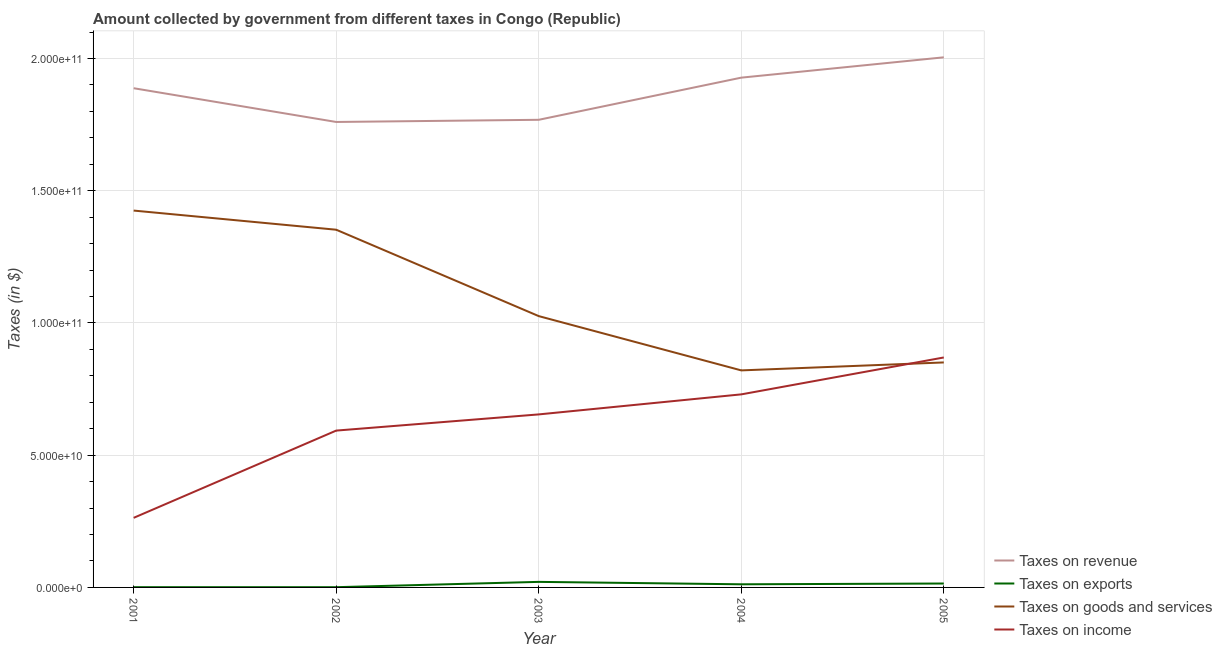How many different coloured lines are there?
Your response must be concise. 4. What is the amount collected as tax on income in 2001?
Your answer should be compact. 2.63e+1. Across all years, what is the maximum amount collected as tax on goods?
Provide a short and direct response. 1.42e+11. Across all years, what is the minimum amount collected as tax on exports?
Ensure brevity in your answer.  9.10e+07. What is the total amount collected as tax on exports in the graph?
Offer a very short reply. 4.95e+09. What is the difference between the amount collected as tax on income in 2001 and that in 2004?
Ensure brevity in your answer.  -4.67e+1. What is the difference between the amount collected as tax on income in 2001 and the amount collected as tax on exports in 2003?
Give a very brief answer. 2.42e+1. What is the average amount collected as tax on goods per year?
Your response must be concise. 1.09e+11. In the year 2001, what is the difference between the amount collected as tax on goods and amount collected as tax on revenue?
Your answer should be very brief. -4.63e+1. In how many years, is the amount collected as tax on revenue greater than 120000000000 $?
Give a very brief answer. 5. What is the ratio of the amount collected as tax on income in 2003 to that in 2005?
Your answer should be very brief. 0.75. Is the amount collected as tax on goods in 2002 less than that in 2003?
Your answer should be compact. No. Is the difference between the amount collected as tax on income in 2002 and 2004 greater than the difference between the amount collected as tax on goods in 2002 and 2004?
Offer a terse response. No. What is the difference between the highest and the second highest amount collected as tax on income?
Provide a short and direct response. 1.40e+1. What is the difference between the highest and the lowest amount collected as tax on income?
Offer a very short reply. 6.06e+1. Is the sum of the amount collected as tax on revenue in 2001 and 2002 greater than the maximum amount collected as tax on goods across all years?
Your answer should be compact. Yes. Is it the case that in every year, the sum of the amount collected as tax on revenue and amount collected as tax on goods is greater than the sum of amount collected as tax on income and amount collected as tax on exports?
Offer a very short reply. Yes. Does the amount collected as tax on exports monotonically increase over the years?
Provide a succinct answer. No. How many years are there in the graph?
Give a very brief answer. 5. What is the difference between two consecutive major ticks on the Y-axis?
Your answer should be compact. 5.00e+1. Does the graph contain grids?
Keep it short and to the point. Yes. Where does the legend appear in the graph?
Give a very brief answer. Bottom right. How many legend labels are there?
Offer a very short reply. 4. How are the legend labels stacked?
Make the answer very short. Vertical. What is the title of the graph?
Ensure brevity in your answer.  Amount collected by government from different taxes in Congo (Republic). Does "Other greenhouse gases" appear as one of the legend labels in the graph?
Give a very brief answer. No. What is the label or title of the Y-axis?
Your answer should be compact. Taxes (in $). What is the Taxes (in $) of Taxes on revenue in 2001?
Your answer should be compact. 1.89e+11. What is the Taxes (in $) in Taxes on exports in 2001?
Provide a short and direct response. 9.72e+07. What is the Taxes (in $) of Taxes on goods and services in 2001?
Your answer should be compact. 1.42e+11. What is the Taxes (in $) in Taxes on income in 2001?
Ensure brevity in your answer.  2.63e+1. What is the Taxes (in $) of Taxes on revenue in 2002?
Provide a short and direct response. 1.76e+11. What is the Taxes (in $) of Taxes on exports in 2002?
Make the answer very short. 9.10e+07. What is the Taxes (in $) of Taxes on goods and services in 2002?
Make the answer very short. 1.35e+11. What is the Taxes (in $) of Taxes on income in 2002?
Ensure brevity in your answer.  5.93e+1. What is the Taxes (in $) in Taxes on revenue in 2003?
Your response must be concise. 1.77e+11. What is the Taxes (in $) in Taxes on exports in 2003?
Provide a short and direct response. 2.10e+09. What is the Taxes (in $) of Taxes on goods and services in 2003?
Offer a terse response. 1.03e+11. What is the Taxes (in $) in Taxes on income in 2003?
Your answer should be very brief. 6.54e+1. What is the Taxes (in $) of Taxes on revenue in 2004?
Keep it short and to the point. 1.93e+11. What is the Taxes (in $) of Taxes on exports in 2004?
Ensure brevity in your answer.  1.18e+09. What is the Taxes (in $) in Taxes on goods and services in 2004?
Ensure brevity in your answer.  8.21e+1. What is the Taxes (in $) in Taxes on income in 2004?
Your answer should be compact. 7.30e+1. What is the Taxes (in $) in Taxes on revenue in 2005?
Ensure brevity in your answer.  2.00e+11. What is the Taxes (in $) in Taxes on exports in 2005?
Your answer should be compact. 1.48e+09. What is the Taxes (in $) of Taxes on goods and services in 2005?
Ensure brevity in your answer.  8.51e+1. What is the Taxes (in $) in Taxes on income in 2005?
Your answer should be very brief. 8.70e+1. Across all years, what is the maximum Taxes (in $) in Taxes on revenue?
Offer a very short reply. 2.00e+11. Across all years, what is the maximum Taxes (in $) in Taxes on exports?
Your response must be concise. 2.10e+09. Across all years, what is the maximum Taxes (in $) of Taxes on goods and services?
Provide a short and direct response. 1.42e+11. Across all years, what is the maximum Taxes (in $) of Taxes on income?
Offer a terse response. 8.70e+1. Across all years, what is the minimum Taxes (in $) in Taxes on revenue?
Your response must be concise. 1.76e+11. Across all years, what is the minimum Taxes (in $) in Taxes on exports?
Provide a short and direct response. 9.10e+07. Across all years, what is the minimum Taxes (in $) of Taxes on goods and services?
Ensure brevity in your answer.  8.21e+1. Across all years, what is the minimum Taxes (in $) in Taxes on income?
Provide a short and direct response. 2.63e+1. What is the total Taxes (in $) of Taxes on revenue in the graph?
Offer a terse response. 9.35e+11. What is the total Taxes (in $) of Taxes on exports in the graph?
Offer a terse response. 4.95e+09. What is the total Taxes (in $) of Taxes on goods and services in the graph?
Keep it short and to the point. 5.47e+11. What is the total Taxes (in $) of Taxes on income in the graph?
Give a very brief answer. 3.11e+11. What is the difference between the Taxes (in $) in Taxes on revenue in 2001 and that in 2002?
Your answer should be compact. 1.28e+1. What is the difference between the Taxes (in $) of Taxes on exports in 2001 and that in 2002?
Your answer should be very brief. 6.21e+06. What is the difference between the Taxes (in $) of Taxes on goods and services in 2001 and that in 2002?
Provide a succinct answer. 7.24e+09. What is the difference between the Taxes (in $) in Taxes on income in 2001 and that in 2002?
Provide a short and direct response. -3.30e+1. What is the difference between the Taxes (in $) in Taxes on revenue in 2001 and that in 2003?
Give a very brief answer. 1.19e+1. What is the difference between the Taxes (in $) in Taxes on exports in 2001 and that in 2003?
Your answer should be compact. -2.00e+09. What is the difference between the Taxes (in $) in Taxes on goods and services in 2001 and that in 2003?
Ensure brevity in your answer.  3.99e+1. What is the difference between the Taxes (in $) of Taxes on income in 2001 and that in 2003?
Give a very brief answer. -3.91e+1. What is the difference between the Taxes (in $) of Taxes on revenue in 2001 and that in 2004?
Give a very brief answer. -4.00e+09. What is the difference between the Taxes (in $) in Taxes on exports in 2001 and that in 2004?
Make the answer very short. -1.09e+09. What is the difference between the Taxes (in $) in Taxes on goods and services in 2001 and that in 2004?
Provide a short and direct response. 6.04e+1. What is the difference between the Taxes (in $) of Taxes on income in 2001 and that in 2004?
Ensure brevity in your answer.  -4.67e+1. What is the difference between the Taxes (in $) in Taxes on revenue in 2001 and that in 2005?
Offer a very short reply. -1.17e+1. What is the difference between the Taxes (in $) of Taxes on exports in 2001 and that in 2005?
Your answer should be very brief. -1.38e+09. What is the difference between the Taxes (in $) in Taxes on goods and services in 2001 and that in 2005?
Your answer should be compact. 5.74e+1. What is the difference between the Taxes (in $) in Taxes on income in 2001 and that in 2005?
Keep it short and to the point. -6.06e+1. What is the difference between the Taxes (in $) of Taxes on revenue in 2002 and that in 2003?
Keep it short and to the point. -8.23e+08. What is the difference between the Taxes (in $) in Taxes on exports in 2002 and that in 2003?
Make the answer very short. -2.01e+09. What is the difference between the Taxes (in $) in Taxes on goods and services in 2002 and that in 2003?
Offer a terse response. 3.27e+1. What is the difference between the Taxes (in $) of Taxes on income in 2002 and that in 2003?
Offer a terse response. -6.12e+09. What is the difference between the Taxes (in $) in Taxes on revenue in 2002 and that in 2004?
Provide a succinct answer. -1.68e+1. What is the difference between the Taxes (in $) of Taxes on exports in 2002 and that in 2004?
Offer a very short reply. -1.09e+09. What is the difference between the Taxes (in $) of Taxes on goods and services in 2002 and that in 2004?
Your answer should be compact. 5.32e+1. What is the difference between the Taxes (in $) of Taxes on income in 2002 and that in 2004?
Give a very brief answer. -1.37e+1. What is the difference between the Taxes (in $) in Taxes on revenue in 2002 and that in 2005?
Keep it short and to the point. -2.44e+1. What is the difference between the Taxes (in $) in Taxes on exports in 2002 and that in 2005?
Give a very brief answer. -1.39e+09. What is the difference between the Taxes (in $) of Taxes on goods and services in 2002 and that in 2005?
Give a very brief answer. 5.02e+1. What is the difference between the Taxes (in $) of Taxes on income in 2002 and that in 2005?
Give a very brief answer. -2.77e+1. What is the difference between the Taxes (in $) in Taxes on revenue in 2003 and that in 2004?
Your answer should be compact. -1.59e+1. What is the difference between the Taxes (in $) in Taxes on exports in 2003 and that in 2004?
Your response must be concise. 9.16e+08. What is the difference between the Taxes (in $) in Taxes on goods and services in 2003 and that in 2004?
Your response must be concise. 2.05e+1. What is the difference between the Taxes (in $) of Taxes on income in 2003 and that in 2004?
Your answer should be compact. -7.58e+09. What is the difference between the Taxes (in $) in Taxes on revenue in 2003 and that in 2005?
Give a very brief answer. -2.36e+1. What is the difference between the Taxes (in $) in Taxes on exports in 2003 and that in 2005?
Your response must be concise. 6.22e+08. What is the difference between the Taxes (in $) in Taxes on goods and services in 2003 and that in 2005?
Your response must be concise. 1.75e+1. What is the difference between the Taxes (in $) in Taxes on income in 2003 and that in 2005?
Provide a short and direct response. -2.15e+1. What is the difference between the Taxes (in $) of Taxes on revenue in 2004 and that in 2005?
Your answer should be compact. -7.69e+09. What is the difference between the Taxes (in $) of Taxes on exports in 2004 and that in 2005?
Keep it short and to the point. -2.94e+08. What is the difference between the Taxes (in $) in Taxes on goods and services in 2004 and that in 2005?
Offer a very short reply. -3.01e+09. What is the difference between the Taxes (in $) of Taxes on income in 2004 and that in 2005?
Provide a succinct answer. -1.40e+1. What is the difference between the Taxes (in $) of Taxes on revenue in 2001 and the Taxes (in $) of Taxes on exports in 2002?
Provide a succinct answer. 1.89e+11. What is the difference between the Taxes (in $) of Taxes on revenue in 2001 and the Taxes (in $) of Taxes on goods and services in 2002?
Offer a terse response. 5.35e+1. What is the difference between the Taxes (in $) of Taxes on revenue in 2001 and the Taxes (in $) of Taxes on income in 2002?
Make the answer very short. 1.29e+11. What is the difference between the Taxes (in $) of Taxes on exports in 2001 and the Taxes (in $) of Taxes on goods and services in 2002?
Provide a succinct answer. -1.35e+11. What is the difference between the Taxes (in $) of Taxes on exports in 2001 and the Taxes (in $) of Taxes on income in 2002?
Provide a short and direct response. -5.92e+1. What is the difference between the Taxes (in $) in Taxes on goods and services in 2001 and the Taxes (in $) in Taxes on income in 2002?
Offer a terse response. 8.32e+1. What is the difference between the Taxes (in $) in Taxes on revenue in 2001 and the Taxes (in $) in Taxes on exports in 2003?
Your response must be concise. 1.87e+11. What is the difference between the Taxes (in $) of Taxes on revenue in 2001 and the Taxes (in $) of Taxes on goods and services in 2003?
Give a very brief answer. 8.62e+1. What is the difference between the Taxes (in $) in Taxes on revenue in 2001 and the Taxes (in $) in Taxes on income in 2003?
Provide a succinct answer. 1.23e+11. What is the difference between the Taxes (in $) of Taxes on exports in 2001 and the Taxes (in $) of Taxes on goods and services in 2003?
Provide a short and direct response. -1.02e+11. What is the difference between the Taxes (in $) in Taxes on exports in 2001 and the Taxes (in $) in Taxes on income in 2003?
Your response must be concise. -6.53e+1. What is the difference between the Taxes (in $) in Taxes on goods and services in 2001 and the Taxes (in $) in Taxes on income in 2003?
Keep it short and to the point. 7.71e+1. What is the difference between the Taxes (in $) of Taxes on revenue in 2001 and the Taxes (in $) of Taxes on exports in 2004?
Keep it short and to the point. 1.88e+11. What is the difference between the Taxes (in $) in Taxes on revenue in 2001 and the Taxes (in $) in Taxes on goods and services in 2004?
Offer a terse response. 1.07e+11. What is the difference between the Taxes (in $) in Taxes on revenue in 2001 and the Taxes (in $) in Taxes on income in 2004?
Keep it short and to the point. 1.16e+11. What is the difference between the Taxes (in $) in Taxes on exports in 2001 and the Taxes (in $) in Taxes on goods and services in 2004?
Keep it short and to the point. -8.20e+1. What is the difference between the Taxes (in $) in Taxes on exports in 2001 and the Taxes (in $) in Taxes on income in 2004?
Ensure brevity in your answer.  -7.29e+1. What is the difference between the Taxes (in $) of Taxes on goods and services in 2001 and the Taxes (in $) of Taxes on income in 2004?
Provide a succinct answer. 6.95e+1. What is the difference between the Taxes (in $) of Taxes on revenue in 2001 and the Taxes (in $) of Taxes on exports in 2005?
Give a very brief answer. 1.87e+11. What is the difference between the Taxes (in $) of Taxes on revenue in 2001 and the Taxes (in $) of Taxes on goods and services in 2005?
Give a very brief answer. 1.04e+11. What is the difference between the Taxes (in $) of Taxes on revenue in 2001 and the Taxes (in $) of Taxes on income in 2005?
Keep it short and to the point. 1.02e+11. What is the difference between the Taxes (in $) of Taxes on exports in 2001 and the Taxes (in $) of Taxes on goods and services in 2005?
Your answer should be compact. -8.50e+1. What is the difference between the Taxes (in $) in Taxes on exports in 2001 and the Taxes (in $) in Taxes on income in 2005?
Your answer should be compact. -8.69e+1. What is the difference between the Taxes (in $) in Taxes on goods and services in 2001 and the Taxes (in $) in Taxes on income in 2005?
Provide a succinct answer. 5.55e+1. What is the difference between the Taxes (in $) of Taxes on revenue in 2002 and the Taxes (in $) of Taxes on exports in 2003?
Make the answer very short. 1.74e+11. What is the difference between the Taxes (in $) in Taxes on revenue in 2002 and the Taxes (in $) in Taxes on goods and services in 2003?
Ensure brevity in your answer.  7.34e+1. What is the difference between the Taxes (in $) of Taxes on revenue in 2002 and the Taxes (in $) of Taxes on income in 2003?
Offer a terse response. 1.11e+11. What is the difference between the Taxes (in $) in Taxes on exports in 2002 and the Taxes (in $) in Taxes on goods and services in 2003?
Your answer should be very brief. -1.03e+11. What is the difference between the Taxes (in $) in Taxes on exports in 2002 and the Taxes (in $) in Taxes on income in 2003?
Give a very brief answer. -6.53e+1. What is the difference between the Taxes (in $) of Taxes on goods and services in 2002 and the Taxes (in $) of Taxes on income in 2003?
Keep it short and to the point. 6.98e+1. What is the difference between the Taxes (in $) in Taxes on revenue in 2002 and the Taxes (in $) in Taxes on exports in 2004?
Offer a terse response. 1.75e+11. What is the difference between the Taxes (in $) in Taxes on revenue in 2002 and the Taxes (in $) in Taxes on goods and services in 2004?
Your answer should be compact. 9.39e+1. What is the difference between the Taxes (in $) of Taxes on revenue in 2002 and the Taxes (in $) of Taxes on income in 2004?
Provide a short and direct response. 1.03e+11. What is the difference between the Taxes (in $) of Taxes on exports in 2002 and the Taxes (in $) of Taxes on goods and services in 2004?
Keep it short and to the point. -8.20e+1. What is the difference between the Taxes (in $) in Taxes on exports in 2002 and the Taxes (in $) in Taxes on income in 2004?
Make the answer very short. -7.29e+1. What is the difference between the Taxes (in $) in Taxes on goods and services in 2002 and the Taxes (in $) in Taxes on income in 2004?
Your response must be concise. 6.23e+1. What is the difference between the Taxes (in $) in Taxes on revenue in 2002 and the Taxes (in $) in Taxes on exports in 2005?
Your answer should be very brief. 1.75e+11. What is the difference between the Taxes (in $) of Taxes on revenue in 2002 and the Taxes (in $) of Taxes on goods and services in 2005?
Your answer should be compact. 9.09e+1. What is the difference between the Taxes (in $) in Taxes on revenue in 2002 and the Taxes (in $) in Taxes on income in 2005?
Give a very brief answer. 8.90e+1. What is the difference between the Taxes (in $) in Taxes on exports in 2002 and the Taxes (in $) in Taxes on goods and services in 2005?
Provide a succinct answer. -8.50e+1. What is the difference between the Taxes (in $) in Taxes on exports in 2002 and the Taxes (in $) in Taxes on income in 2005?
Make the answer very short. -8.69e+1. What is the difference between the Taxes (in $) of Taxes on goods and services in 2002 and the Taxes (in $) of Taxes on income in 2005?
Keep it short and to the point. 4.83e+1. What is the difference between the Taxes (in $) of Taxes on revenue in 2003 and the Taxes (in $) of Taxes on exports in 2004?
Your answer should be compact. 1.76e+11. What is the difference between the Taxes (in $) of Taxes on revenue in 2003 and the Taxes (in $) of Taxes on goods and services in 2004?
Your response must be concise. 9.48e+1. What is the difference between the Taxes (in $) in Taxes on revenue in 2003 and the Taxes (in $) in Taxes on income in 2004?
Offer a very short reply. 1.04e+11. What is the difference between the Taxes (in $) in Taxes on exports in 2003 and the Taxes (in $) in Taxes on goods and services in 2004?
Your answer should be compact. -8.00e+1. What is the difference between the Taxes (in $) of Taxes on exports in 2003 and the Taxes (in $) of Taxes on income in 2004?
Make the answer very short. -7.09e+1. What is the difference between the Taxes (in $) in Taxes on goods and services in 2003 and the Taxes (in $) in Taxes on income in 2004?
Your answer should be compact. 2.96e+1. What is the difference between the Taxes (in $) of Taxes on revenue in 2003 and the Taxes (in $) of Taxes on exports in 2005?
Your answer should be compact. 1.75e+11. What is the difference between the Taxes (in $) in Taxes on revenue in 2003 and the Taxes (in $) in Taxes on goods and services in 2005?
Provide a succinct answer. 9.17e+1. What is the difference between the Taxes (in $) in Taxes on revenue in 2003 and the Taxes (in $) in Taxes on income in 2005?
Provide a succinct answer. 8.99e+1. What is the difference between the Taxes (in $) in Taxes on exports in 2003 and the Taxes (in $) in Taxes on goods and services in 2005?
Keep it short and to the point. -8.30e+1. What is the difference between the Taxes (in $) of Taxes on exports in 2003 and the Taxes (in $) of Taxes on income in 2005?
Your response must be concise. -8.49e+1. What is the difference between the Taxes (in $) of Taxes on goods and services in 2003 and the Taxes (in $) of Taxes on income in 2005?
Provide a succinct answer. 1.56e+1. What is the difference between the Taxes (in $) of Taxes on revenue in 2004 and the Taxes (in $) of Taxes on exports in 2005?
Provide a succinct answer. 1.91e+11. What is the difference between the Taxes (in $) in Taxes on revenue in 2004 and the Taxes (in $) in Taxes on goods and services in 2005?
Your response must be concise. 1.08e+11. What is the difference between the Taxes (in $) in Taxes on revenue in 2004 and the Taxes (in $) in Taxes on income in 2005?
Provide a short and direct response. 1.06e+11. What is the difference between the Taxes (in $) in Taxes on exports in 2004 and the Taxes (in $) in Taxes on goods and services in 2005?
Your answer should be compact. -8.39e+1. What is the difference between the Taxes (in $) of Taxes on exports in 2004 and the Taxes (in $) of Taxes on income in 2005?
Your answer should be very brief. -8.58e+1. What is the difference between the Taxes (in $) of Taxes on goods and services in 2004 and the Taxes (in $) of Taxes on income in 2005?
Keep it short and to the point. -4.89e+09. What is the average Taxes (in $) of Taxes on revenue per year?
Offer a terse response. 1.87e+11. What is the average Taxes (in $) in Taxes on exports per year?
Keep it short and to the point. 9.90e+08. What is the average Taxes (in $) in Taxes on goods and services per year?
Keep it short and to the point. 1.09e+11. What is the average Taxes (in $) of Taxes on income per year?
Offer a terse response. 6.22e+1. In the year 2001, what is the difference between the Taxes (in $) in Taxes on revenue and Taxes (in $) in Taxes on exports?
Make the answer very short. 1.89e+11. In the year 2001, what is the difference between the Taxes (in $) in Taxes on revenue and Taxes (in $) in Taxes on goods and services?
Keep it short and to the point. 4.63e+1. In the year 2001, what is the difference between the Taxes (in $) in Taxes on revenue and Taxes (in $) in Taxes on income?
Give a very brief answer. 1.62e+11. In the year 2001, what is the difference between the Taxes (in $) in Taxes on exports and Taxes (in $) in Taxes on goods and services?
Offer a very short reply. -1.42e+11. In the year 2001, what is the difference between the Taxes (in $) of Taxes on exports and Taxes (in $) of Taxes on income?
Give a very brief answer. -2.62e+1. In the year 2001, what is the difference between the Taxes (in $) of Taxes on goods and services and Taxes (in $) of Taxes on income?
Your response must be concise. 1.16e+11. In the year 2002, what is the difference between the Taxes (in $) of Taxes on revenue and Taxes (in $) of Taxes on exports?
Provide a short and direct response. 1.76e+11. In the year 2002, what is the difference between the Taxes (in $) of Taxes on revenue and Taxes (in $) of Taxes on goods and services?
Your response must be concise. 4.07e+1. In the year 2002, what is the difference between the Taxes (in $) of Taxes on revenue and Taxes (in $) of Taxes on income?
Keep it short and to the point. 1.17e+11. In the year 2002, what is the difference between the Taxes (in $) of Taxes on exports and Taxes (in $) of Taxes on goods and services?
Keep it short and to the point. -1.35e+11. In the year 2002, what is the difference between the Taxes (in $) in Taxes on exports and Taxes (in $) in Taxes on income?
Provide a succinct answer. -5.92e+1. In the year 2002, what is the difference between the Taxes (in $) in Taxes on goods and services and Taxes (in $) in Taxes on income?
Make the answer very short. 7.60e+1. In the year 2003, what is the difference between the Taxes (in $) in Taxes on revenue and Taxes (in $) in Taxes on exports?
Give a very brief answer. 1.75e+11. In the year 2003, what is the difference between the Taxes (in $) of Taxes on revenue and Taxes (in $) of Taxes on goods and services?
Offer a terse response. 7.42e+1. In the year 2003, what is the difference between the Taxes (in $) of Taxes on revenue and Taxes (in $) of Taxes on income?
Give a very brief answer. 1.11e+11. In the year 2003, what is the difference between the Taxes (in $) of Taxes on exports and Taxes (in $) of Taxes on goods and services?
Keep it short and to the point. -1.00e+11. In the year 2003, what is the difference between the Taxes (in $) of Taxes on exports and Taxes (in $) of Taxes on income?
Your answer should be very brief. -6.33e+1. In the year 2003, what is the difference between the Taxes (in $) in Taxes on goods and services and Taxes (in $) in Taxes on income?
Your answer should be very brief. 3.72e+1. In the year 2004, what is the difference between the Taxes (in $) of Taxes on revenue and Taxes (in $) of Taxes on exports?
Your answer should be compact. 1.92e+11. In the year 2004, what is the difference between the Taxes (in $) in Taxes on revenue and Taxes (in $) in Taxes on goods and services?
Provide a succinct answer. 1.11e+11. In the year 2004, what is the difference between the Taxes (in $) of Taxes on revenue and Taxes (in $) of Taxes on income?
Provide a succinct answer. 1.20e+11. In the year 2004, what is the difference between the Taxes (in $) in Taxes on exports and Taxes (in $) in Taxes on goods and services?
Offer a very short reply. -8.09e+1. In the year 2004, what is the difference between the Taxes (in $) of Taxes on exports and Taxes (in $) of Taxes on income?
Your answer should be compact. -7.18e+1. In the year 2004, what is the difference between the Taxes (in $) of Taxes on goods and services and Taxes (in $) of Taxes on income?
Your response must be concise. 9.07e+09. In the year 2005, what is the difference between the Taxes (in $) in Taxes on revenue and Taxes (in $) in Taxes on exports?
Make the answer very short. 1.99e+11. In the year 2005, what is the difference between the Taxes (in $) in Taxes on revenue and Taxes (in $) in Taxes on goods and services?
Make the answer very short. 1.15e+11. In the year 2005, what is the difference between the Taxes (in $) of Taxes on revenue and Taxes (in $) of Taxes on income?
Ensure brevity in your answer.  1.13e+11. In the year 2005, what is the difference between the Taxes (in $) in Taxes on exports and Taxes (in $) in Taxes on goods and services?
Keep it short and to the point. -8.36e+1. In the year 2005, what is the difference between the Taxes (in $) in Taxes on exports and Taxes (in $) in Taxes on income?
Offer a very short reply. -8.55e+1. In the year 2005, what is the difference between the Taxes (in $) of Taxes on goods and services and Taxes (in $) of Taxes on income?
Ensure brevity in your answer.  -1.88e+09. What is the ratio of the Taxes (in $) of Taxes on revenue in 2001 to that in 2002?
Your response must be concise. 1.07. What is the ratio of the Taxes (in $) of Taxes on exports in 2001 to that in 2002?
Keep it short and to the point. 1.07. What is the ratio of the Taxes (in $) in Taxes on goods and services in 2001 to that in 2002?
Offer a terse response. 1.05. What is the ratio of the Taxes (in $) in Taxes on income in 2001 to that in 2002?
Give a very brief answer. 0.44. What is the ratio of the Taxes (in $) of Taxes on revenue in 2001 to that in 2003?
Your answer should be compact. 1.07. What is the ratio of the Taxes (in $) of Taxes on exports in 2001 to that in 2003?
Offer a very short reply. 0.05. What is the ratio of the Taxes (in $) in Taxes on goods and services in 2001 to that in 2003?
Make the answer very short. 1.39. What is the ratio of the Taxes (in $) in Taxes on income in 2001 to that in 2003?
Your response must be concise. 0.4. What is the ratio of the Taxes (in $) in Taxes on revenue in 2001 to that in 2004?
Your answer should be compact. 0.98. What is the ratio of the Taxes (in $) of Taxes on exports in 2001 to that in 2004?
Provide a short and direct response. 0.08. What is the ratio of the Taxes (in $) of Taxes on goods and services in 2001 to that in 2004?
Offer a very short reply. 1.74. What is the ratio of the Taxes (in $) of Taxes on income in 2001 to that in 2004?
Offer a terse response. 0.36. What is the ratio of the Taxes (in $) of Taxes on revenue in 2001 to that in 2005?
Ensure brevity in your answer.  0.94. What is the ratio of the Taxes (in $) in Taxes on exports in 2001 to that in 2005?
Keep it short and to the point. 0.07. What is the ratio of the Taxes (in $) of Taxes on goods and services in 2001 to that in 2005?
Ensure brevity in your answer.  1.68. What is the ratio of the Taxes (in $) in Taxes on income in 2001 to that in 2005?
Your answer should be compact. 0.3. What is the ratio of the Taxes (in $) in Taxes on revenue in 2002 to that in 2003?
Ensure brevity in your answer.  1. What is the ratio of the Taxes (in $) in Taxes on exports in 2002 to that in 2003?
Make the answer very short. 0.04. What is the ratio of the Taxes (in $) of Taxes on goods and services in 2002 to that in 2003?
Make the answer very short. 1.32. What is the ratio of the Taxes (in $) of Taxes on income in 2002 to that in 2003?
Your answer should be compact. 0.91. What is the ratio of the Taxes (in $) of Taxes on revenue in 2002 to that in 2004?
Provide a succinct answer. 0.91. What is the ratio of the Taxes (in $) in Taxes on exports in 2002 to that in 2004?
Offer a terse response. 0.08. What is the ratio of the Taxes (in $) in Taxes on goods and services in 2002 to that in 2004?
Provide a succinct answer. 1.65. What is the ratio of the Taxes (in $) in Taxes on income in 2002 to that in 2004?
Make the answer very short. 0.81. What is the ratio of the Taxes (in $) in Taxes on revenue in 2002 to that in 2005?
Provide a short and direct response. 0.88. What is the ratio of the Taxes (in $) in Taxes on exports in 2002 to that in 2005?
Make the answer very short. 0.06. What is the ratio of the Taxes (in $) in Taxes on goods and services in 2002 to that in 2005?
Your answer should be very brief. 1.59. What is the ratio of the Taxes (in $) in Taxes on income in 2002 to that in 2005?
Provide a succinct answer. 0.68. What is the ratio of the Taxes (in $) of Taxes on revenue in 2003 to that in 2004?
Provide a succinct answer. 0.92. What is the ratio of the Taxes (in $) in Taxes on exports in 2003 to that in 2004?
Keep it short and to the point. 1.77. What is the ratio of the Taxes (in $) of Taxes on goods and services in 2003 to that in 2004?
Give a very brief answer. 1.25. What is the ratio of the Taxes (in $) of Taxes on income in 2003 to that in 2004?
Your answer should be compact. 0.9. What is the ratio of the Taxes (in $) in Taxes on revenue in 2003 to that in 2005?
Provide a short and direct response. 0.88. What is the ratio of the Taxes (in $) in Taxes on exports in 2003 to that in 2005?
Your answer should be compact. 1.42. What is the ratio of the Taxes (in $) of Taxes on goods and services in 2003 to that in 2005?
Provide a succinct answer. 1.21. What is the ratio of the Taxes (in $) in Taxes on income in 2003 to that in 2005?
Make the answer very short. 0.75. What is the ratio of the Taxes (in $) of Taxes on revenue in 2004 to that in 2005?
Offer a very short reply. 0.96. What is the ratio of the Taxes (in $) of Taxes on exports in 2004 to that in 2005?
Give a very brief answer. 0.8. What is the ratio of the Taxes (in $) in Taxes on goods and services in 2004 to that in 2005?
Offer a terse response. 0.96. What is the ratio of the Taxes (in $) in Taxes on income in 2004 to that in 2005?
Ensure brevity in your answer.  0.84. What is the difference between the highest and the second highest Taxes (in $) of Taxes on revenue?
Keep it short and to the point. 7.69e+09. What is the difference between the highest and the second highest Taxes (in $) of Taxes on exports?
Your answer should be very brief. 6.22e+08. What is the difference between the highest and the second highest Taxes (in $) of Taxes on goods and services?
Make the answer very short. 7.24e+09. What is the difference between the highest and the second highest Taxes (in $) of Taxes on income?
Give a very brief answer. 1.40e+1. What is the difference between the highest and the lowest Taxes (in $) in Taxes on revenue?
Provide a succinct answer. 2.44e+1. What is the difference between the highest and the lowest Taxes (in $) in Taxes on exports?
Provide a succinct answer. 2.01e+09. What is the difference between the highest and the lowest Taxes (in $) of Taxes on goods and services?
Give a very brief answer. 6.04e+1. What is the difference between the highest and the lowest Taxes (in $) of Taxes on income?
Offer a very short reply. 6.06e+1. 